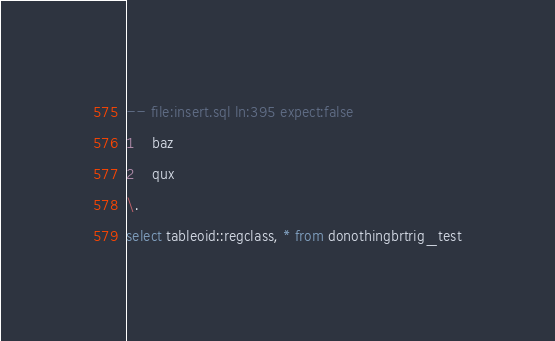Convert code to text. <code><loc_0><loc_0><loc_500><loc_500><_SQL_>-- file:insert.sql ln:395 expect:false
1	baz
2	qux
\.
select tableoid::regclass, * from donothingbrtrig_test
</code> 